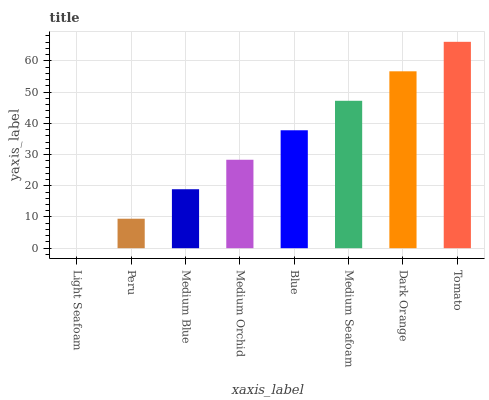Is Light Seafoam the minimum?
Answer yes or no. Yes. Is Tomato the maximum?
Answer yes or no. Yes. Is Peru the minimum?
Answer yes or no. No. Is Peru the maximum?
Answer yes or no. No. Is Peru greater than Light Seafoam?
Answer yes or no. Yes. Is Light Seafoam less than Peru?
Answer yes or no. Yes. Is Light Seafoam greater than Peru?
Answer yes or no. No. Is Peru less than Light Seafoam?
Answer yes or no. No. Is Blue the high median?
Answer yes or no. Yes. Is Medium Orchid the low median?
Answer yes or no. Yes. Is Medium Seafoam the high median?
Answer yes or no. No. Is Medium Blue the low median?
Answer yes or no. No. 